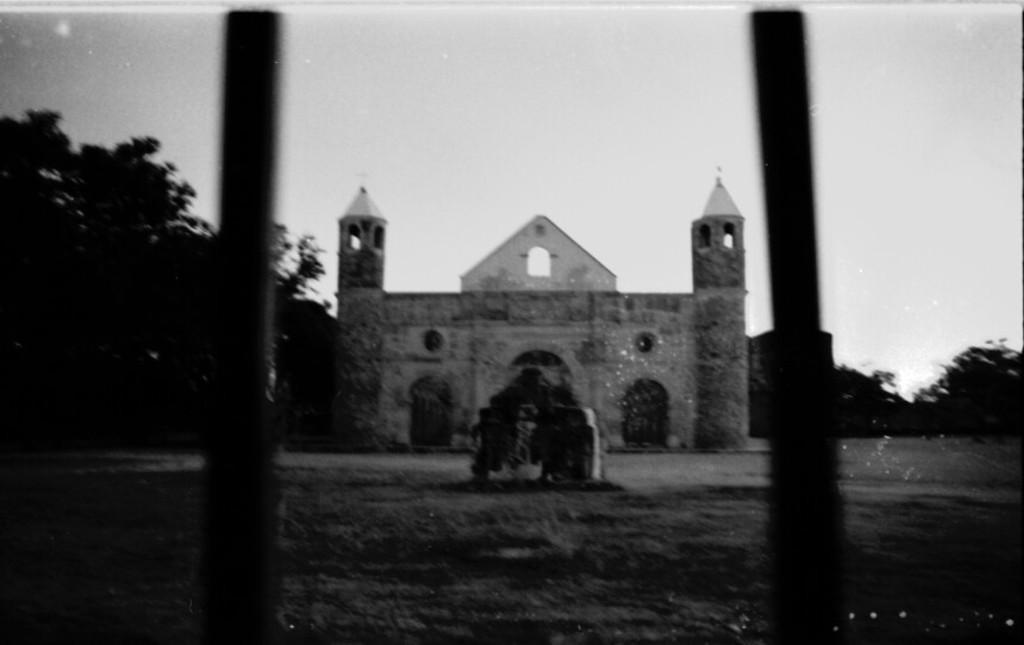In one or two sentences, can you explain what this image depicts? This is a black and white image. In the foreground, I can see two poles on the ground. In the background there is a building, on both sides of the building I can see the trees. On the top of the image I can see the sky. 